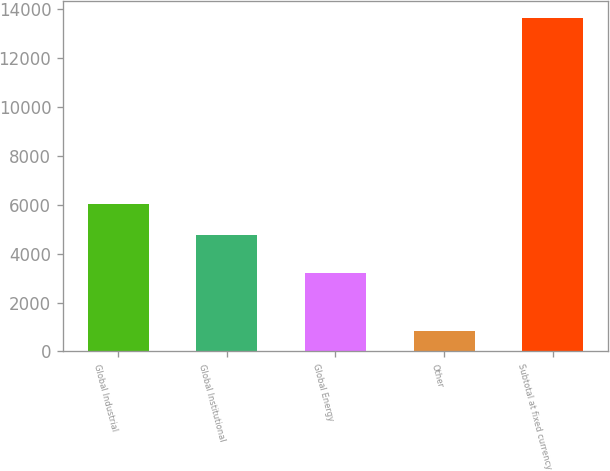Convert chart to OTSL. <chart><loc_0><loc_0><loc_500><loc_500><bar_chart><fcel>Global Industrial<fcel>Global Institutional<fcel>Global Energy<fcel>Other<fcel>Subtotal at fixed currency<nl><fcel>6027.17<fcel>4744.9<fcel>3199.3<fcel>823.5<fcel>13646.2<nl></chart> 